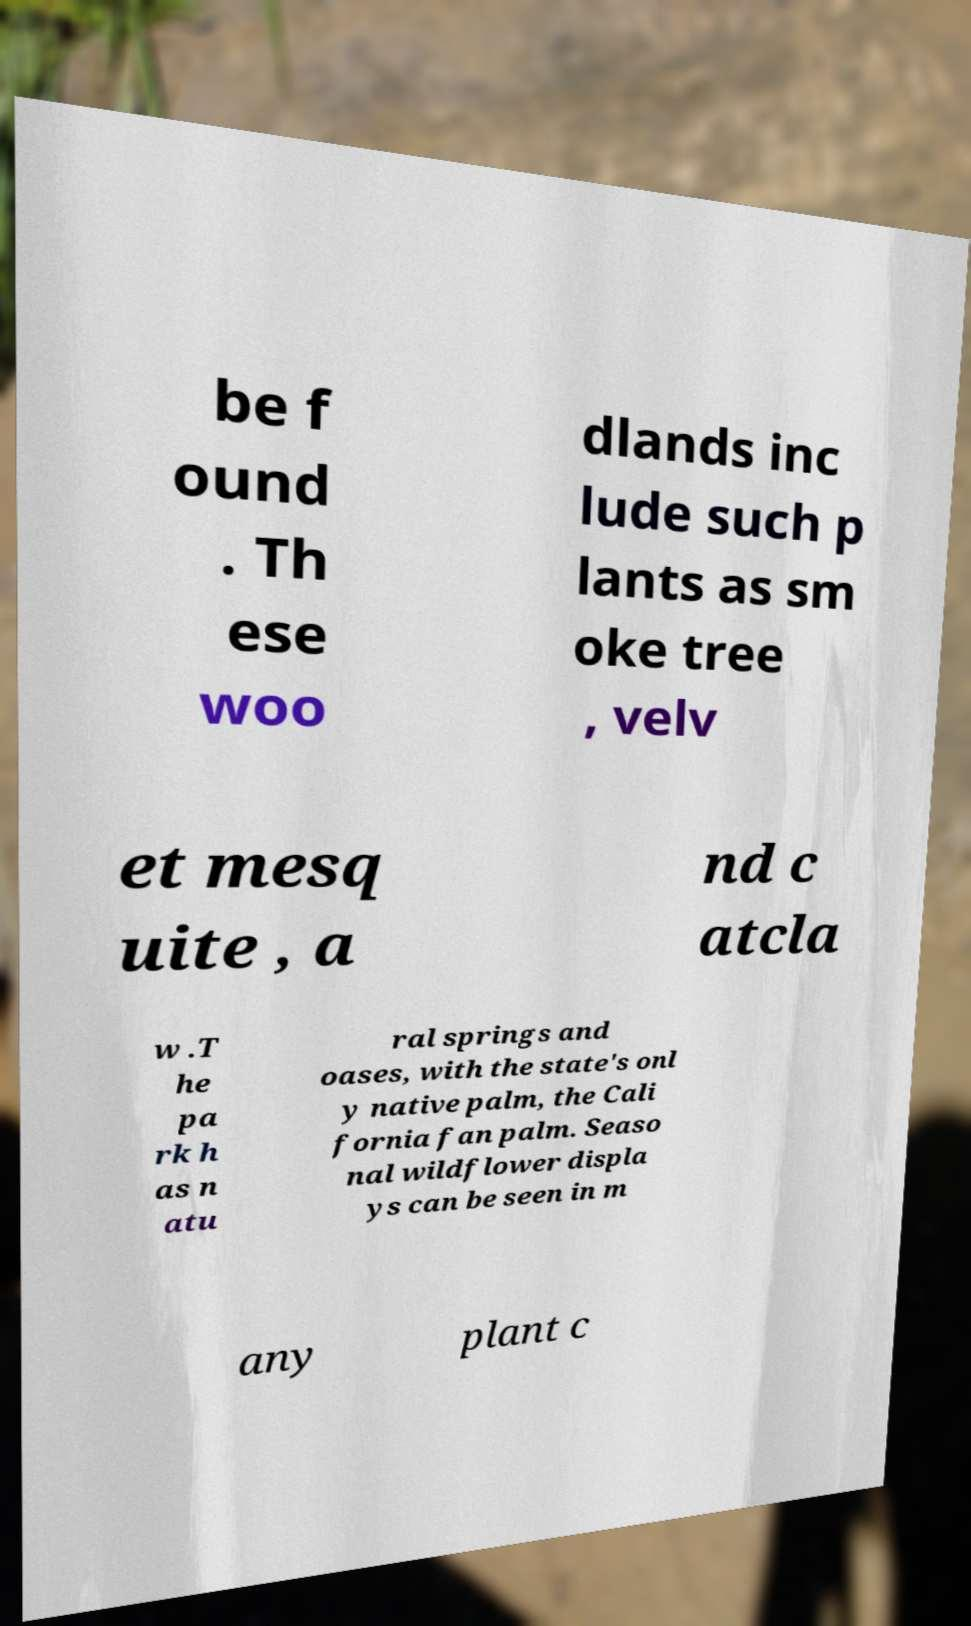There's text embedded in this image that I need extracted. Can you transcribe it verbatim? be f ound . Th ese woo dlands inc lude such p lants as sm oke tree , velv et mesq uite , a nd c atcla w .T he pa rk h as n atu ral springs and oases, with the state's onl y native palm, the Cali fornia fan palm. Seaso nal wildflower displa ys can be seen in m any plant c 